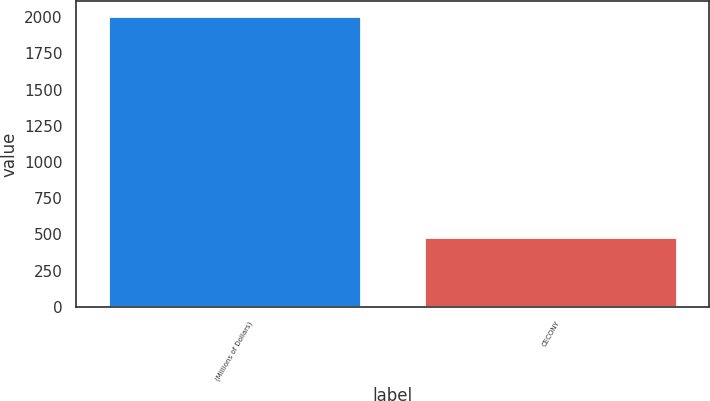Convert chart to OTSL. <chart><loc_0><loc_0><loc_500><loc_500><bar_chart><fcel>(Millions of Dollars)<fcel>CECONY<nl><fcel>2011<fcel>480<nl></chart> 